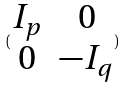Convert formula to latex. <formula><loc_0><loc_0><loc_500><loc_500>( \begin{matrix} I _ { p } & 0 \\ 0 & - I _ { q } \end{matrix} )</formula> 